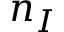Convert formula to latex. <formula><loc_0><loc_0><loc_500><loc_500>n _ { I }</formula> 